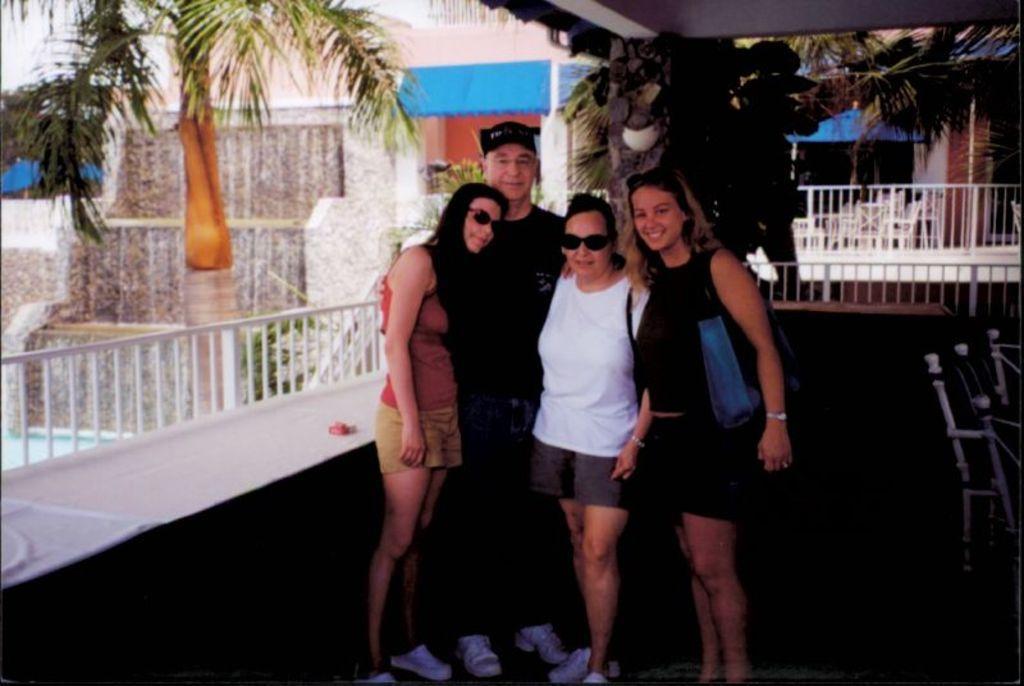In one or two sentences, can you explain what this image depicts? In this image there are three women and a man standing, with a smile on their face are posing for the camera, behind them there is a metal fence, behind the metal fence there are trees and a building. 